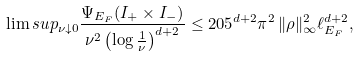<formula> <loc_0><loc_0><loc_500><loc_500>\lim s u p _ { \nu \downarrow 0 } \frac { \Psi _ { E _ { F } } ( I _ { + } \times I _ { - } ) } { \nu ^ { 2 } \left ( \log \frac { 1 } { \nu } \right ) ^ { d + 2 } } \leq { 2 0 5 } ^ { d + 2 } { \pi ^ { 2 } } \, \| \rho \| _ { \infty } ^ { 2 } { \ell } _ { E _ { F } } ^ { d + 2 } ,</formula> 